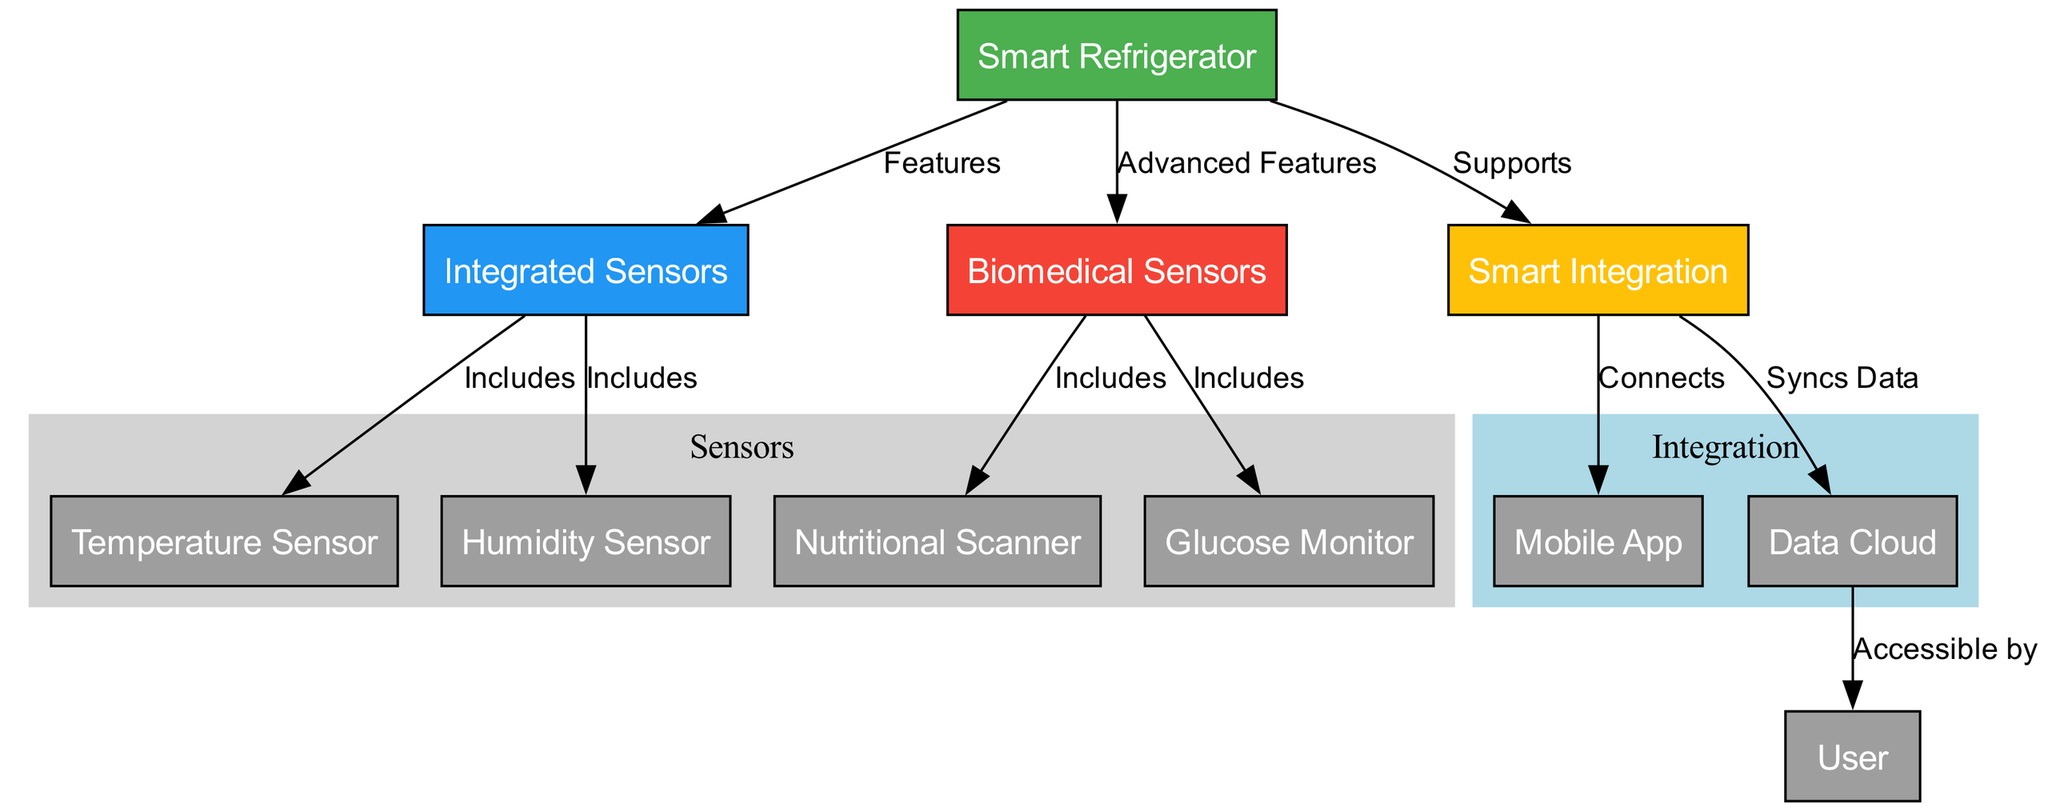What is the main entity in this diagram? The main entity is represented by the node labeled "Smart Refrigerator," which is the central component of the diagram that connects to various features and functionalities.
Answer: Smart Refrigerator How many biomedical sensors are shown in the diagram? The diagram shows two biomedical sensors: the "Nutritional Scanner" and the "Glucose Monitor." To find this, we can count the nodes listed under the biomedical sensors category.
Answer: 2 What connects the smart integration to the mobile app? The connection is established through the edge labeled "Connects" that links the "Smart Integration" node to the "Mobile App" node.
Answer: Mobile App Which sensor is included under integrated sensors besides the temperature sensor? The "Humidity Sensor" is included as an additional sensor under the integrated sensors, indicated by the edge labeled "Includes." This can be found by examining the edges connecting to the "Integrated Sensors" node.
Answer: Humidity Sensor What is accessible by the user in the diagram structure? The "Data Cloud" is indicated as being accessible by the "User," demonstrated by the edge labeled "Accessible by," which directly links the data cloud to the user node.
Answer: Data Cloud Which feature supports advanced functions in the smart refrigerator? The "Biomedical Sensors" node represents the advanced features of the smart refrigerator, as indicated by the edge labeled "Advanced Features" connecting it to the smart refrigerator node.
Answer: Biomedical Sensors What type of data does the smart integration sync? The "Data Cloud" is the entity that syncs data, as indicated by the edge labeled "Syncs Data" linking it from the "Smart Integration." This clearly shows the flow of data management in the system.
Answer: Syncs Data How many total nodes are in the diagram? There are eleven nodes in total as counted by reviewing the distinct elements labeled in the diagram. A thorough count of the nodes provides this total.
Answer: 11 What role does the mobile app play in relation to the smart refrigerator? The "Mobile App" is connected to the "Smart Integration," which indicates it plays a role in managing and controlling the functions of the smart refrigerator through connectivity, shown by the edge labeled "Connects."
Answer: Connects 